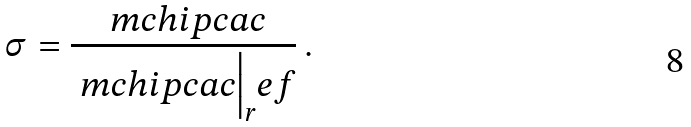Convert formula to latex. <formula><loc_0><loc_0><loc_500><loc_500>\sigma = \frac { \ m c h i p c a c } { \Big . \ m c h i p c a c \Big | _ { r } e f } \, .</formula> 